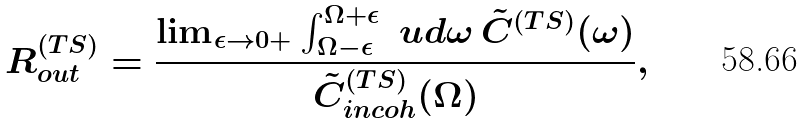Convert formula to latex. <formula><loc_0><loc_0><loc_500><loc_500>R _ { o u t } ^ { ( T S ) } = \frac { \lim _ { \epsilon \rightarrow 0 + } \int _ { \Omega - \epsilon } ^ { \Omega + \epsilon } \ u d \omega \, \tilde { C } ^ { ( T S ) } ( \omega ) } { \tilde { C } _ { i n c o h } ^ { ( T S ) } ( \Omega ) } ,</formula> 